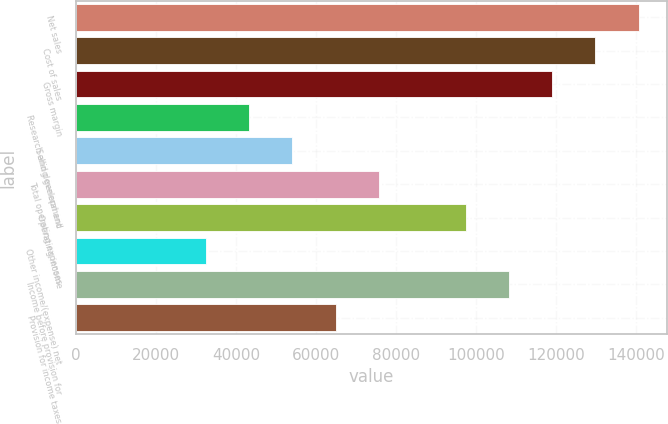<chart> <loc_0><loc_0><loc_500><loc_500><bar_chart><fcel>Net sales<fcel>Cost of sales<fcel>Gross margin<fcel>Research and development<fcel>Selling general and<fcel>Total operating expenses<fcel>Operating income<fcel>Other income/(expense) net<fcel>Income before provision for<fcel>Provision for income taxes<nl><fcel>140722<fcel>129898<fcel>119074<fcel>43302.2<fcel>54126.7<fcel>75775.6<fcel>97424.6<fcel>32477.8<fcel>108249<fcel>64951.2<nl></chart> 